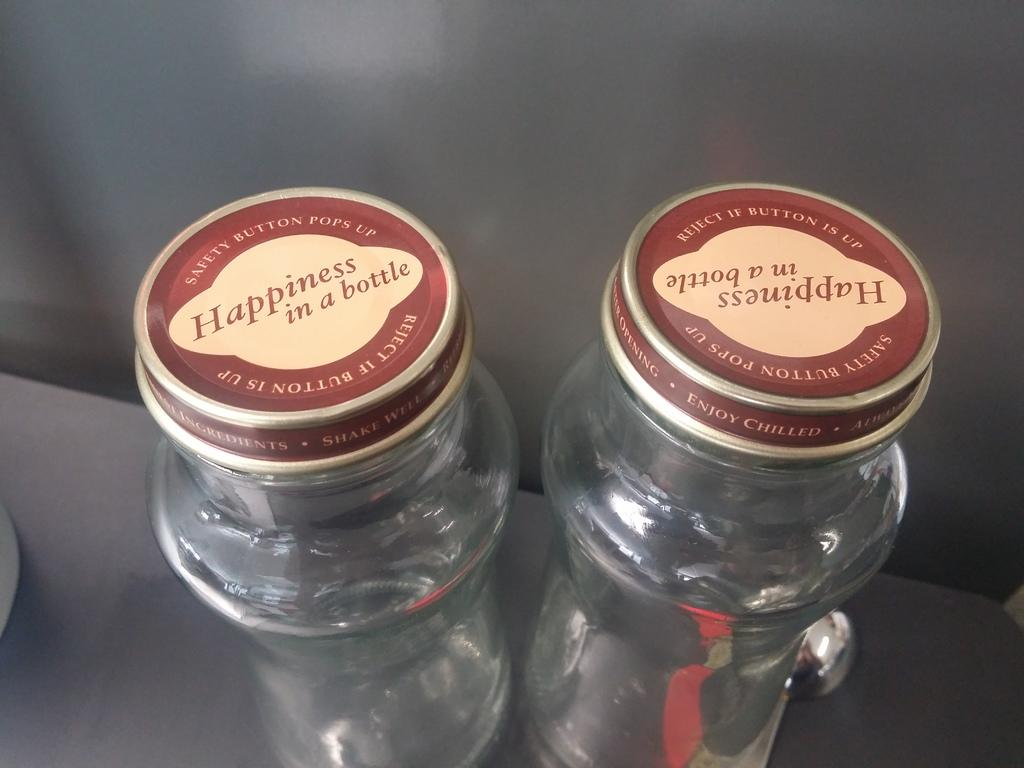<image>
Share a concise interpretation of the image provided. Cap of a bottle that says "Happiness In a Bottle". 